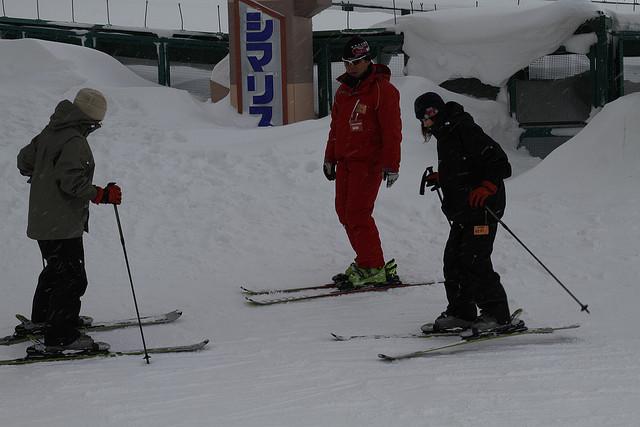How many skiers don't have poles?
Concise answer only. 1. How many people are skiing?
Quick response, please. 3. What sport are the people in the scene prepared for?
Be succinct. Skiing. Is the skier closest to the camera wearing a black jacket?
Give a very brief answer. Yes. Are the two skiers traveling in the same direction?
Answer briefly. Yes. What is the male on the right dressed as?
Answer briefly. Skier. What color is the sign behind the adult and child?
Keep it brief. Blue and white. How many people are in this photo?
Be succinct. 3. 